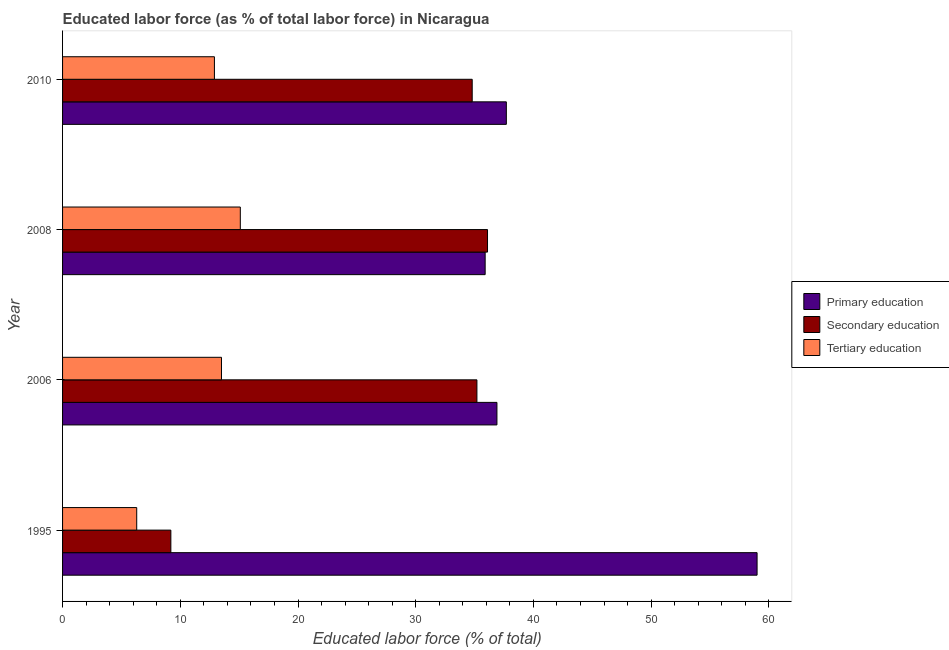How many groups of bars are there?
Keep it short and to the point. 4. Are the number of bars per tick equal to the number of legend labels?
Your answer should be compact. Yes. How many bars are there on the 2nd tick from the bottom?
Give a very brief answer. 3. What is the label of the 3rd group of bars from the top?
Make the answer very short. 2006. In how many cases, is the number of bars for a given year not equal to the number of legend labels?
Keep it short and to the point. 0. What is the percentage of labor force who received tertiary education in 2008?
Keep it short and to the point. 15.1. Across all years, what is the maximum percentage of labor force who received secondary education?
Provide a short and direct response. 36.1. Across all years, what is the minimum percentage of labor force who received primary education?
Ensure brevity in your answer.  35.9. What is the total percentage of labor force who received primary education in the graph?
Provide a succinct answer. 169.5. What is the difference between the percentage of labor force who received secondary education in 1995 and that in 2008?
Ensure brevity in your answer.  -26.9. What is the difference between the percentage of labor force who received primary education in 1995 and the percentage of labor force who received tertiary education in 2010?
Provide a succinct answer. 46.1. What is the average percentage of labor force who received secondary education per year?
Offer a very short reply. 28.82. In the year 1995, what is the difference between the percentage of labor force who received secondary education and percentage of labor force who received primary education?
Your response must be concise. -49.8. In how many years, is the percentage of labor force who received tertiary education greater than 42 %?
Offer a very short reply. 0. What is the ratio of the percentage of labor force who received secondary education in 2006 to that in 2010?
Ensure brevity in your answer.  1.01. Is the percentage of labor force who received primary education in 1995 less than that in 2006?
Your response must be concise. No. Is the difference between the percentage of labor force who received primary education in 2006 and 2008 greater than the difference between the percentage of labor force who received secondary education in 2006 and 2008?
Offer a very short reply. Yes. What is the difference between the highest and the second highest percentage of labor force who received secondary education?
Ensure brevity in your answer.  0.9. What is the difference between the highest and the lowest percentage of labor force who received primary education?
Provide a short and direct response. 23.1. Is the sum of the percentage of labor force who received tertiary education in 2006 and 2010 greater than the maximum percentage of labor force who received secondary education across all years?
Offer a terse response. No. What does the 1st bar from the top in 2006 represents?
Offer a very short reply. Tertiary education. Are all the bars in the graph horizontal?
Make the answer very short. Yes. How many years are there in the graph?
Offer a terse response. 4. Are the values on the major ticks of X-axis written in scientific E-notation?
Give a very brief answer. No. Where does the legend appear in the graph?
Offer a very short reply. Center right. How many legend labels are there?
Make the answer very short. 3. How are the legend labels stacked?
Your answer should be compact. Vertical. What is the title of the graph?
Provide a succinct answer. Educated labor force (as % of total labor force) in Nicaragua. What is the label or title of the X-axis?
Keep it short and to the point. Educated labor force (% of total). What is the Educated labor force (% of total) of Secondary education in 1995?
Provide a short and direct response. 9.2. What is the Educated labor force (% of total) of Tertiary education in 1995?
Offer a very short reply. 6.3. What is the Educated labor force (% of total) in Primary education in 2006?
Provide a succinct answer. 36.9. What is the Educated labor force (% of total) of Secondary education in 2006?
Keep it short and to the point. 35.2. What is the Educated labor force (% of total) in Tertiary education in 2006?
Ensure brevity in your answer.  13.5. What is the Educated labor force (% of total) in Primary education in 2008?
Ensure brevity in your answer.  35.9. What is the Educated labor force (% of total) in Secondary education in 2008?
Make the answer very short. 36.1. What is the Educated labor force (% of total) in Tertiary education in 2008?
Your answer should be very brief. 15.1. What is the Educated labor force (% of total) of Primary education in 2010?
Offer a very short reply. 37.7. What is the Educated labor force (% of total) in Secondary education in 2010?
Offer a terse response. 34.8. What is the Educated labor force (% of total) in Tertiary education in 2010?
Offer a very short reply. 12.9. Across all years, what is the maximum Educated labor force (% of total) of Secondary education?
Give a very brief answer. 36.1. Across all years, what is the maximum Educated labor force (% of total) of Tertiary education?
Make the answer very short. 15.1. Across all years, what is the minimum Educated labor force (% of total) in Primary education?
Your answer should be very brief. 35.9. Across all years, what is the minimum Educated labor force (% of total) of Secondary education?
Offer a terse response. 9.2. Across all years, what is the minimum Educated labor force (% of total) in Tertiary education?
Ensure brevity in your answer.  6.3. What is the total Educated labor force (% of total) in Primary education in the graph?
Provide a succinct answer. 169.5. What is the total Educated labor force (% of total) of Secondary education in the graph?
Provide a short and direct response. 115.3. What is the total Educated labor force (% of total) in Tertiary education in the graph?
Offer a terse response. 47.8. What is the difference between the Educated labor force (% of total) in Primary education in 1995 and that in 2006?
Give a very brief answer. 22.1. What is the difference between the Educated labor force (% of total) of Primary education in 1995 and that in 2008?
Offer a terse response. 23.1. What is the difference between the Educated labor force (% of total) of Secondary education in 1995 and that in 2008?
Your response must be concise. -26.9. What is the difference between the Educated labor force (% of total) in Primary education in 1995 and that in 2010?
Your response must be concise. 21.3. What is the difference between the Educated labor force (% of total) of Secondary education in 1995 and that in 2010?
Provide a succinct answer. -25.6. What is the difference between the Educated labor force (% of total) of Primary education in 2006 and that in 2008?
Keep it short and to the point. 1. What is the difference between the Educated labor force (% of total) of Primary education in 2008 and that in 2010?
Provide a succinct answer. -1.8. What is the difference between the Educated labor force (% of total) in Primary education in 1995 and the Educated labor force (% of total) in Secondary education in 2006?
Ensure brevity in your answer.  23.8. What is the difference between the Educated labor force (% of total) of Primary education in 1995 and the Educated labor force (% of total) of Tertiary education in 2006?
Provide a succinct answer. 45.5. What is the difference between the Educated labor force (% of total) in Primary education in 1995 and the Educated labor force (% of total) in Secondary education in 2008?
Provide a short and direct response. 22.9. What is the difference between the Educated labor force (% of total) of Primary education in 1995 and the Educated labor force (% of total) of Tertiary education in 2008?
Give a very brief answer. 43.9. What is the difference between the Educated labor force (% of total) of Secondary education in 1995 and the Educated labor force (% of total) of Tertiary education in 2008?
Your answer should be very brief. -5.9. What is the difference between the Educated labor force (% of total) in Primary education in 1995 and the Educated labor force (% of total) in Secondary education in 2010?
Your answer should be very brief. 24.2. What is the difference between the Educated labor force (% of total) in Primary education in 1995 and the Educated labor force (% of total) in Tertiary education in 2010?
Provide a short and direct response. 46.1. What is the difference between the Educated labor force (% of total) in Secondary education in 1995 and the Educated labor force (% of total) in Tertiary education in 2010?
Ensure brevity in your answer.  -3.7. What is the difference between the Educated labor force (% of total) of Primary education in 2006 and the Educated labor force (% of total) of Tertiary education in 2008?
Make the answer very short. 21.8. What is the difference between the Educated labor force (% of total) of Secondary education in 2006 and the Educated labor force (% of total) of Tertiary education in 2008?
Offer a very short reply. 20.1. What is the difference between the Educated labor force (% of total) in Primary education in 2006 and the Educated labor force (% of total) in Tertiary education in 2010?
Offer a terse response. 24. What is the difference between the Educated labor force (% of total) in Secondary education in 2006 and the Educated labor force (% of total) in Tertiary education in 2010?
Provide a short and direct response. 22.3. What is the difference between the Educated labor force (% of total) of Secondary education in 2008 and the Educated labor force (% of total) of Tertiary education in 2010?
Your answer should be very brief. 23.2. What is the average Educated labor force (% of total) of Primary education per year?
Give a very brief answer. 42.38. What is the average Educated labor force (% of total) of Secondary education per year?
Keep it short and to the point. 28.82. What is the average Educated labor force (% of total) of Tertiary education per year?
Offer a very short reply. 11.95. In the year 1995, what is the difference between the Educated labor force (% of total) in Primary education and Educated labor force (% of total) in Secondary education?
Provide a succinct answer. 49.8. In the year 1995, what is the difference between the Educated labor force (% of total) of Primary education and Educated labor force (% of total) of Tertiary education?
Keep it short and to the point. 52.7. In the year 1995, what is the difference between the Educated labor force (% of total) in Secondary education and Educated labor force (% of total) in Tertiary education?
Offer a very short reply. 2.9. In the year 2006, what is the difference between the Educated labor force (% of total) of Primary education and Educated labor force (% of total) of Secondary education?
Provide a succinct answer. 1.7. In the year 2006, what is the difference between the Educated labor force (% of total) of Primary education and Educated labor force (% of total) of Tertiary education?
Provide a short and direct response. 23.4. In the year 2006, what is the difference between the Educated labor force (% of total) in Secondary education and Educated labor force (% of total) in Tertiary education?
Provide a short and direct response. 21.7. In the year 2008, what is the difference between the Educated labor force (% of total) in Primary education and Educated labor force (% of total) in Secondary education?
Your response must be concise. -0.2. In the year 2008, what is the difference between the Educated labor force (% of total) in Primary education and Educated labor force (% of total) in Tertiary education?
Offer a terse response. 20.8. In the year 2008, what is the difference between the Educated labor force (% of total) in Secondary education and Educated labor force (% of total) in Tertiary education?
Give a very brief answer. 21. In the year 2010, what is the difference between the Educated labor force (% of total) in Primary education and Educated labor force (% of total) in Tertiary education?
Provide a short and direct response. 24.8. In the year 2010, what is the difference between the Educated labor force (% of total) in Secondary education and Educated labor force (% of total) in Tertiary education?
Give a very brief answer. 21.9. What is the ratio of the Educated labor force (% of total) of Primary education in 1995 to that in 2006?
Provide a succinct answer. 1.6. What is the ratio of the Educated labor force (% of total) in Secondary education in 1995 to that in 2006?
Offer a very short reply. 0.26. What is the ratio of the Educated labor force (% of total) of Tertiary education in 1995 to that in 2006?
Provide a short and direct response. 0.47. What is the ratio of the Educated labor force (% of total) in Primary education in 1995 to that in 2008?
Keep it short and to the point. 1.64. What is the ratio of the Educated labor force (% of total) in Secondary education in 1995 to that in 2008?
Your response must be concise. 0.25. What is the ratio of the Educated labor force (% of total) in Tertiary education in 1995 to that in 2008?
Ensure brevity in your answer.  0.42. What is the ratio of the Educated labor force (% of total) in Primary education in 1995 to that in 2010?
Your response must be concise. 1.56. What is the ratio of the Educated labor force (% of total) in Secondary education in 1995 to that in 2010?
Your answer should be compact. 0.26. What is the ratio of the Educated labor force (% of total) in Tertiary education in 1995 to that in 2010?
Ensure brevity in your answer.  0.49. What is the ratio of the Educated labor force (% of total) of Primary education in 2006 to that in 2008?
Provide a short and direct response. 1.03. What is the ratio of the Educated labor force (% of total) of Secondary education in 2006 to that in 2008?
Give a very brief answer. 0.98. What is the ratio of the Educated labor force (% of total) of Tertiary education in 2006 to that in 2008?
Ensure brevity in your answer.  0.89. What is the ratio of the Educated labor force (% of total) of Primary education in 2006 to that in 2010?
Keep it short and to the point. 0.98. What is the ratio of the Educated labor force (% of total) of Secondary education in 2006 to that in 2010?
Keep it short and to the point. 1.01. What is the ratio of the Educated labor force (% of total) of Tertiary education in 2006 to that in 2010?
Make the answer very short. 1.05. What is the ratio of the Educated labor force (% of total) in Primary education in 2008 to that in 2010?
Make the answer very short. 0.95. What is the ratio of the Educated labor force (% of total) in Secondary education in 2008 to that in 2010?
Give a very brief answer. 1.04. What is the ratio of the Educated labor force (% of total) in Tertiary education in 2008 to that in 2010?
Ensure brevity in your answer.  1.17. What is the difference between the highest and the second highest Educated labor force (% of total) of Primary education?
Your answer should be compact. 21.3. What is the difference between the highest and the second highest Educated labor force (% of total) in Tertiary education?
Give a very brief answer. 1.6. What is the difference between the highest and the lowest Educated labor force (% of total) in Primary education?
Make the answer very short. 23.1. What is the difference between the highest and the lowest Educated labor force (% of total) of Secondary education?
Offer a very short reply. 26.9. What is the difference between the highest and the lowest Educated labor force (% of total) in Tertiary education?
Offer a very short reply. 8.8. 